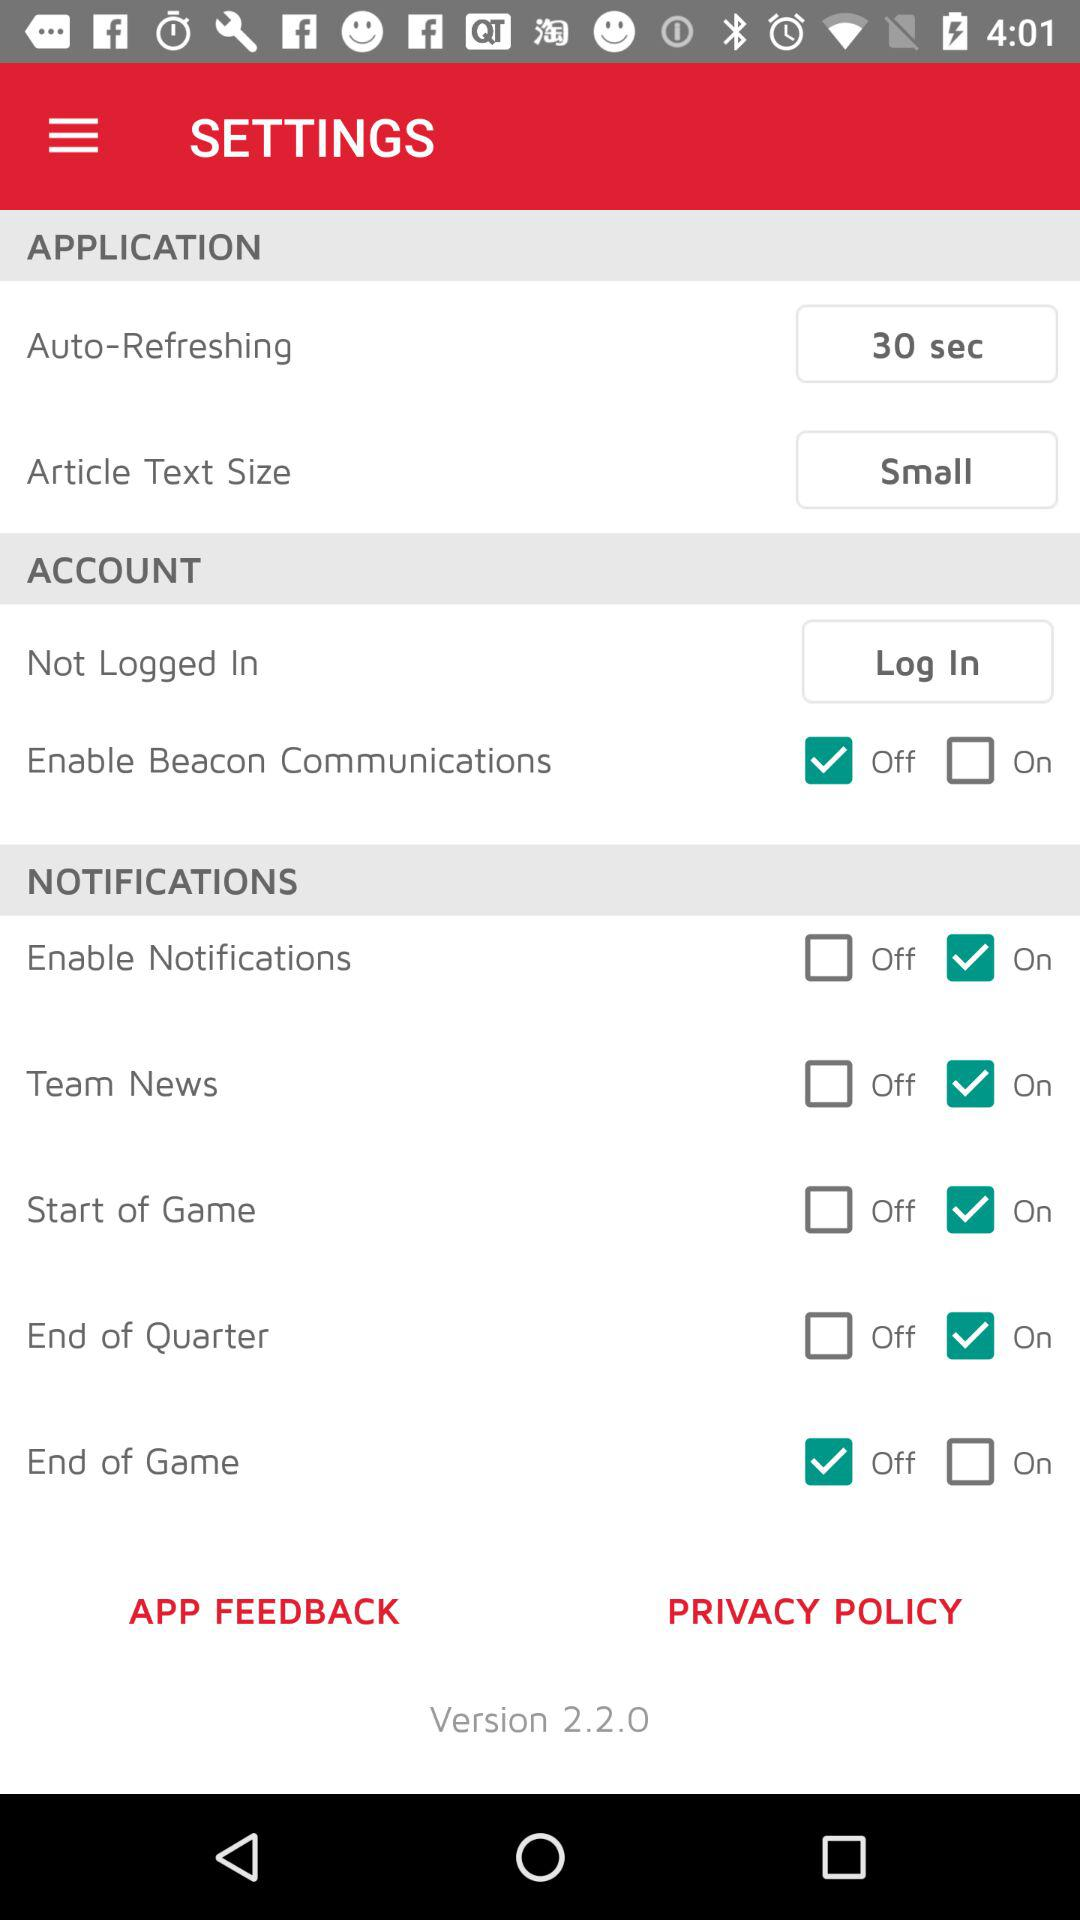How many more items are in the Notifications section than the Account section?
Answer the question using a single word or phrase. 4 